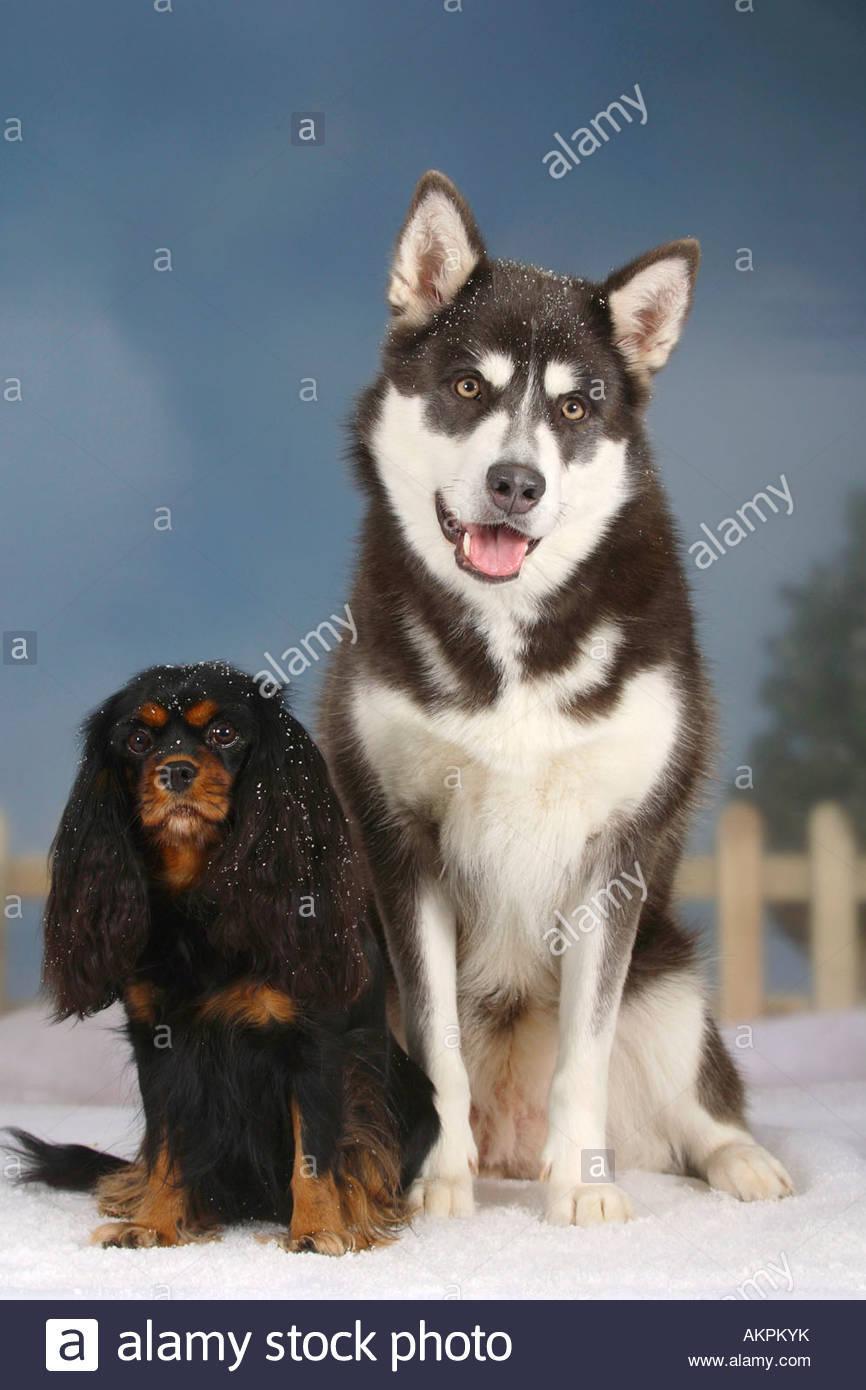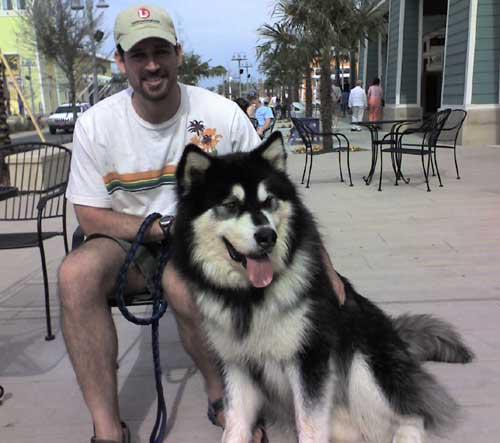The first image is the image on the left, the second image is the image on the right. Considering the images on both sides, is "In one image, at least one dog has its mouth open, and in the other image, no dogs have their mouth open." valid? Answer yes or no. No. The first image is the image on the left, the second image is the image on the right. Assess this claim about the two images: "The left image shows a smaller black-and-tan spaniel sitting to the left of a taller black-and-white sitting husky with open mouth and upright ears.". Correct or not? Answer yes or no. Yes. 